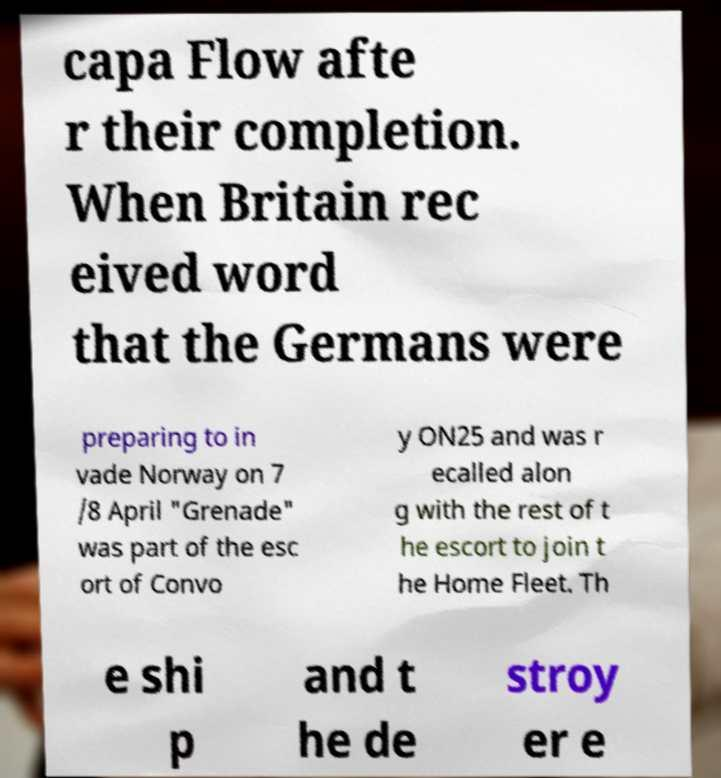What messages or text are displayed in this image? I need them in a readable, typed format. capa Flow afte r their completion. When Britain rec eived word that the Germans were preparing to in vade Norway on 7 /8 April "Grenade" was part of the esc ort of Convo y ON25 and was r ecalled alon g with the rest of t he escort to join t he Home Fleet. Th e shi p and t he de stroy er e 